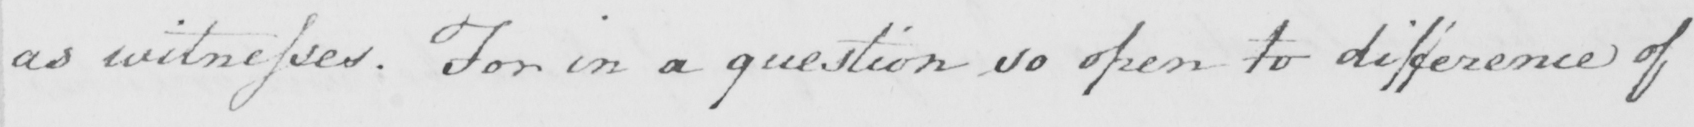What does this handwritten line say? as witnesses . For in a question so open to difference of 